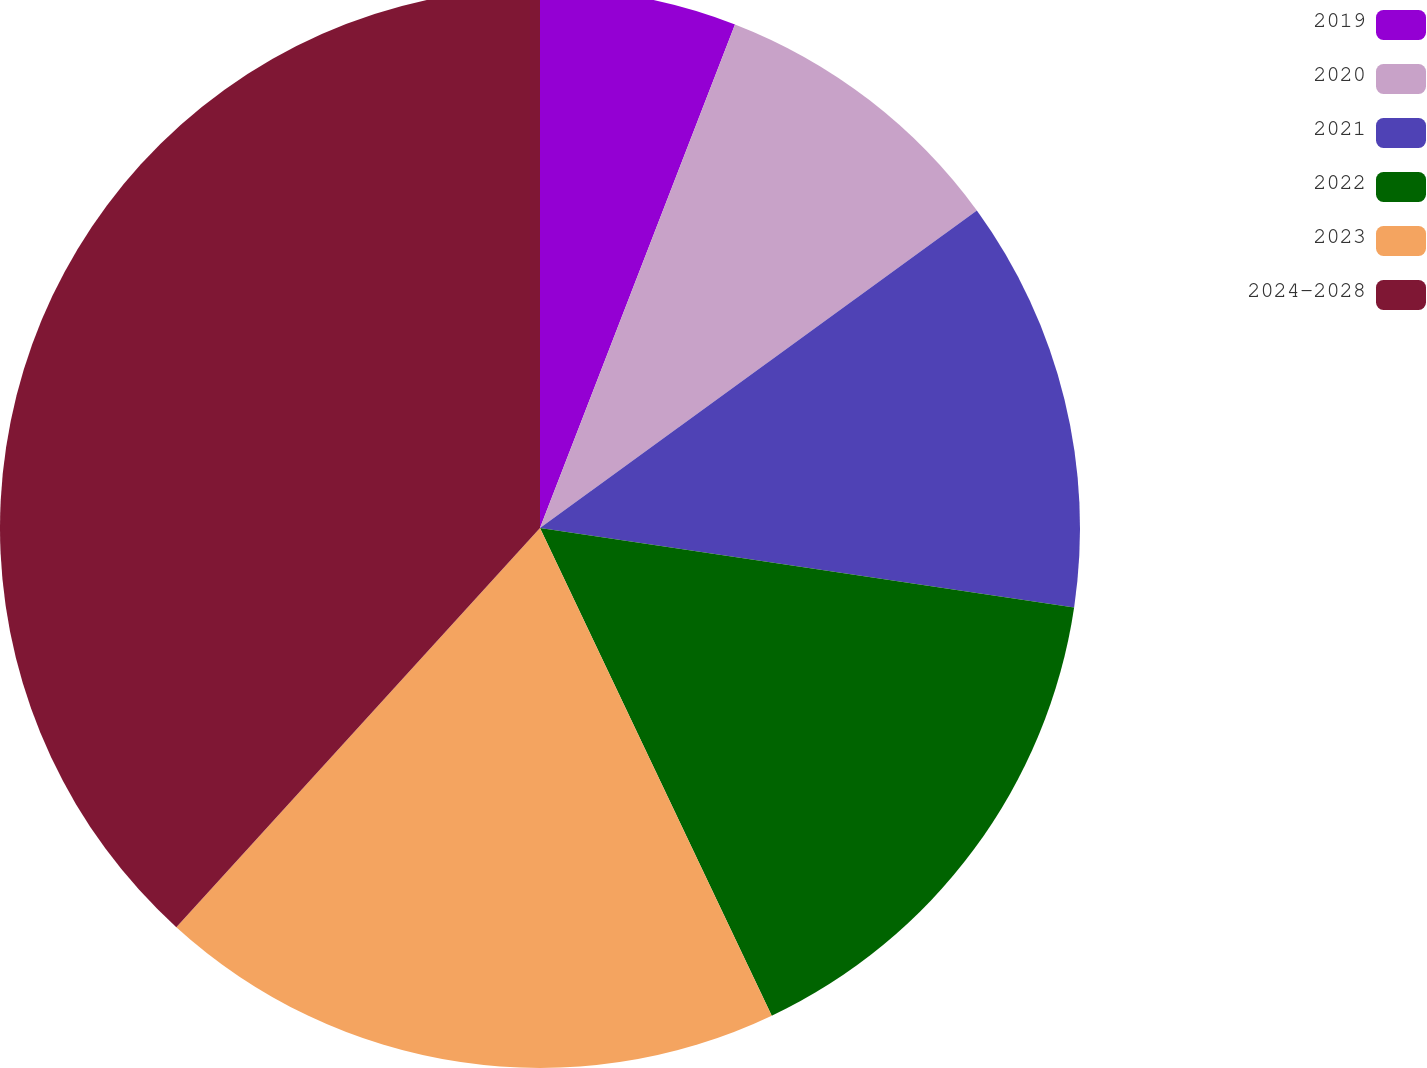<chart> <loc_0><loc_0><loc_500><loc_500><pie_chart><fcel>2019<fcel>2020<fcel>2021<fcel>2022<fcel>2023<fcel>2024-2028<nl><fcel>5.88%<fcel>9.12%<fcel>12.35%<fcel>15.59%<fcel>18.82%<fcel>38.24%<nl></chart> 